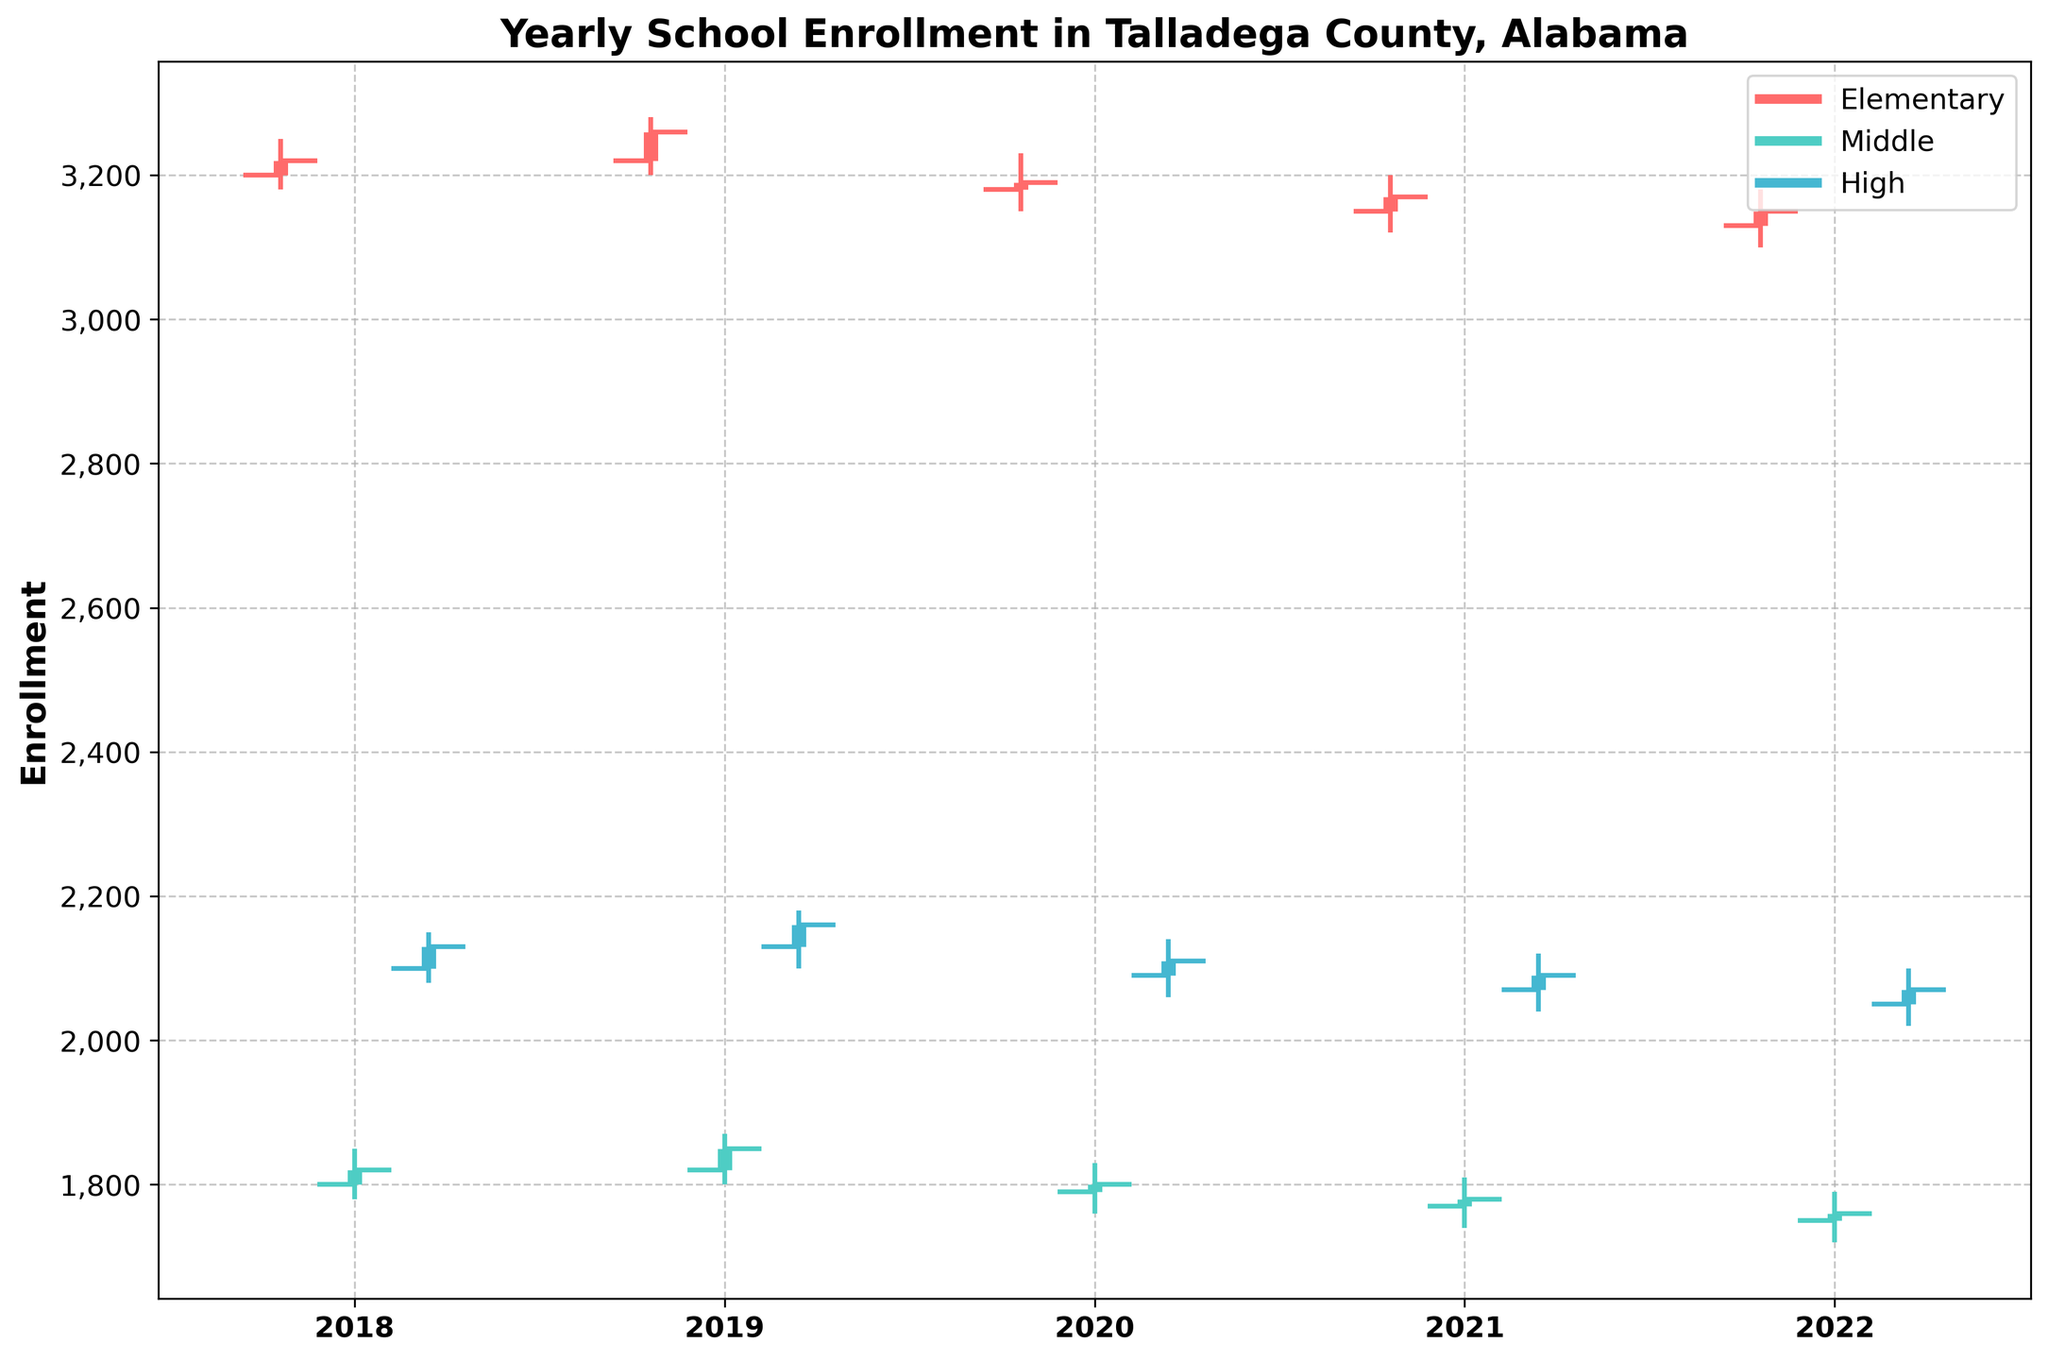What is the title of the figure? The title of the figure can be found at the top of the chart. It is written in bold and is the main heading that describes the data being visualized.
Answer: Yearly School Enrollment in Talladega County, Alabama What are the three levels of education shown on the chart? The chart uses different colors to differentiate the three levels of education. The levels are also labeled in the figure legend, located in the upper right corner.
Answer: Elementary, Middle, High What is the enrollment difference between the highest and the lowest value for Elementary level in 2019? The highest enrollment value for Elementary in 2019 is 3280, and the lowest is 3200. The difference between them is calculated by subtracting the lowest value from the highest value.
Answer: 80 Which year had the highest closing enrollment for High School? The closing enrollment for each year is represented by the thick part of the vertical lines. By examining these values for the High School level, the highest closing value is seen in 2019 with a closing enrollment of 2160.
Answer: 2019 How does the Elementary school enrollment trend over the years? To determine the trend, we look at the closing enrollment numbers for Elementary school over the years from 2018 to 2022. These numbers are decreasing, indicating a downward trend.
Answer: Decreasing In what year was the Middle school enrollment the most stable, showing the smallest difference between high and low values? We need to compare the difference between the high and low values for each year for Middle school. The year with the smallest difference is 2021 (between 1810 and 1740, a difference of 70).
Answer: 2021 What is the average closing enrollment across all levels in 2020? To find the average, we sum the closing enrollments for Elementary (3190), Middle (1800), and High (2110) in 2020, and then divide by 3. (3190 + 1800 + 2110) / 3 = 7100 / 3.
Answer: 2366.67 Which education level had the lowest opening enrollment in any given year and what was that value? By examining the opening enrollments for each level across all years, the lowest value is for Middle school in 2022 with an opening enrollment of 1750.
Answer: Middle, 1750 Compare the high enrollment values between Elementary and High School in 2018. Which one is higher and by how much? The high enrollment value for Elementary in 2018 is 3250 and for High School is 2150. The difference is calculated by subtracting the High School value from the Elementary value. 3250 - 2150 = 1100.
Answer: Elementary, 1100 How did the closing enrollment for Middle school change from 2018 to 2022? By comparing the closing enrollments for Middle school in 2018 (1820) and 2022 (1760), the change can be calculated as 1760 - 1820, which results in a decrease.
Answer: Decreased by 60 